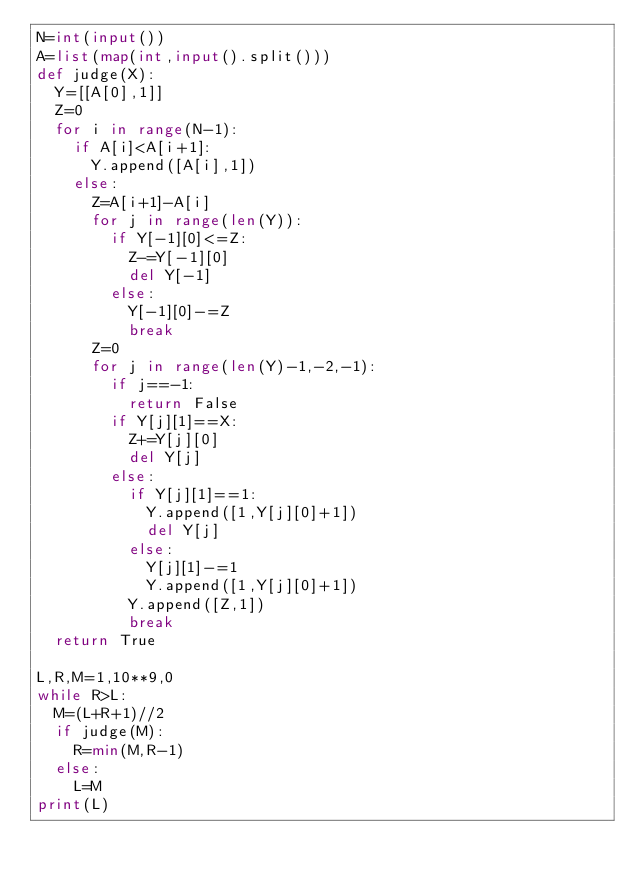<code> <loc_0><loc_0><loc_500><loc_500><_Python_>N=int(input())
A=list(map(int,input().split()))
def judge(X):
  Y=[[A[0],1]]
  Z=0
  for i in range(N-1):
    if A[i]<A[i+1]:
      Y.append([A[i],1])
    else:
      Z=A[i+1]-A[i]
      for j in range(len(Y)):
        if Y[-1][0]<=Z:
          Z-=Y[-1][0]
          del Y[-1]
        else:
          Y[-1][0]-=Z
          break
      Z=0
      for j in range(len(Y)-1,-2,-1):
        if j==-1:
          return False
        if Y[j][1]==X:
          Z+=Y[j][0]
          del Y[j]
        else:
          if Y[j][1]==1:
            Y.append([1,Y[j][0]+1])
            del Y[j]
          else:
            Y[j][1]-=1
            Y.append([1,Y[j][0]+1])
          Y.append([Z,1])
          break
  return True

L,R,M=1,10**9,0
while R>L:
  M=(L+R+1)//2
  if judge(M):
    R=min(M,R-1)
  else:
    L=M
print(L)</code> 